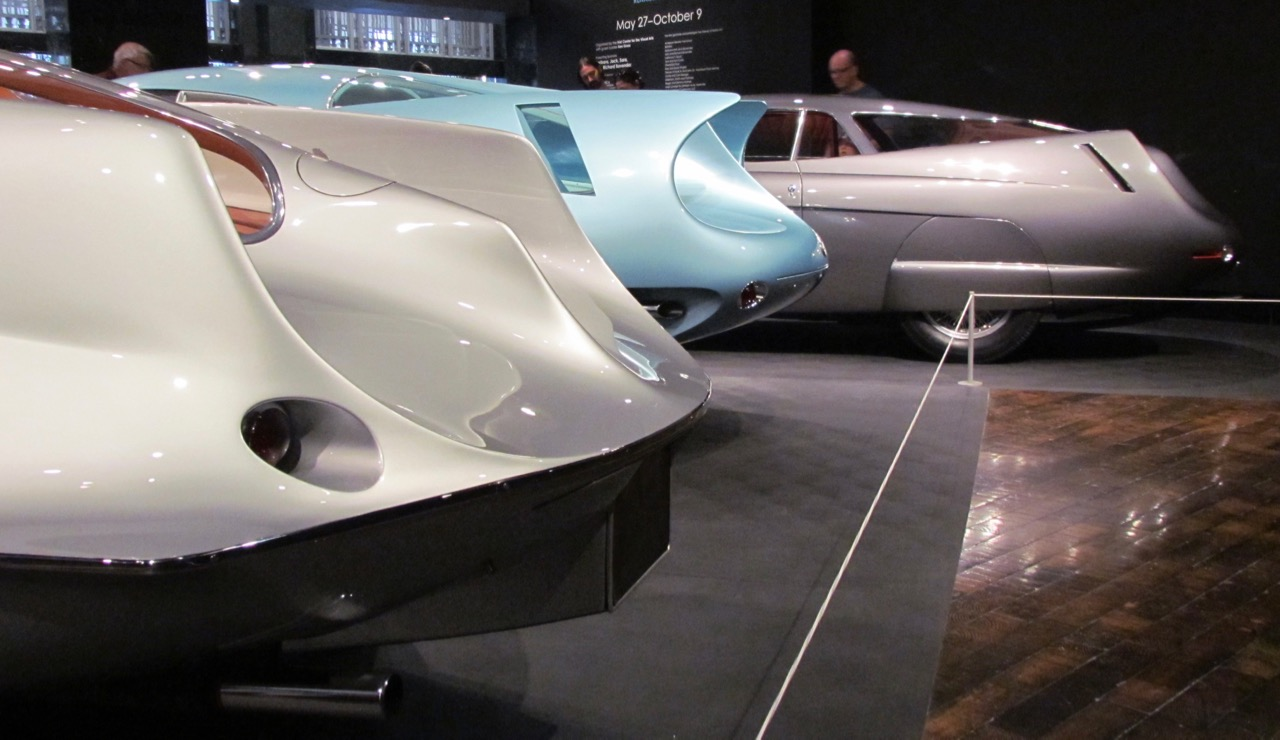Considering the unique design elements visible on the cars, such as the teardrop shape and the circular side vents, which automotive design era and movement do these cars most likely represent, and what might have been the inspiration behind such distinctive features? These cars most likely represent the automotive design era of the 1930s to the 1950s, during which streamlining and aerodynamic efficiency were key design trends. This era marked a fascination with speed and futuristic aesthetics, heavily influenced by advancements in aircraft and naval engineering. The teardrop shape and circular side vents seen on these cars were designed to minimize air resistance, a principle borrowed from aviation and used to create vehicles that seemed fast and dynamic, even when stationary. This design approach was not just about performance; it also conveyed a sense of modernity and progress, resonating with the cultural themes of efficiency, innovation, and the exciting promise of the future. 